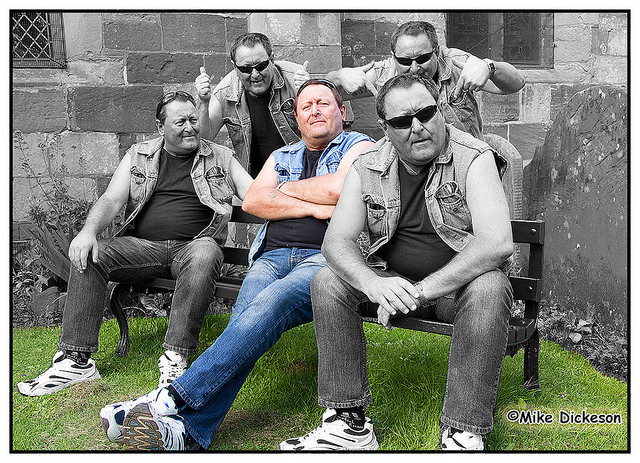Please extract the text content from this image. C MIKE Dickeson 